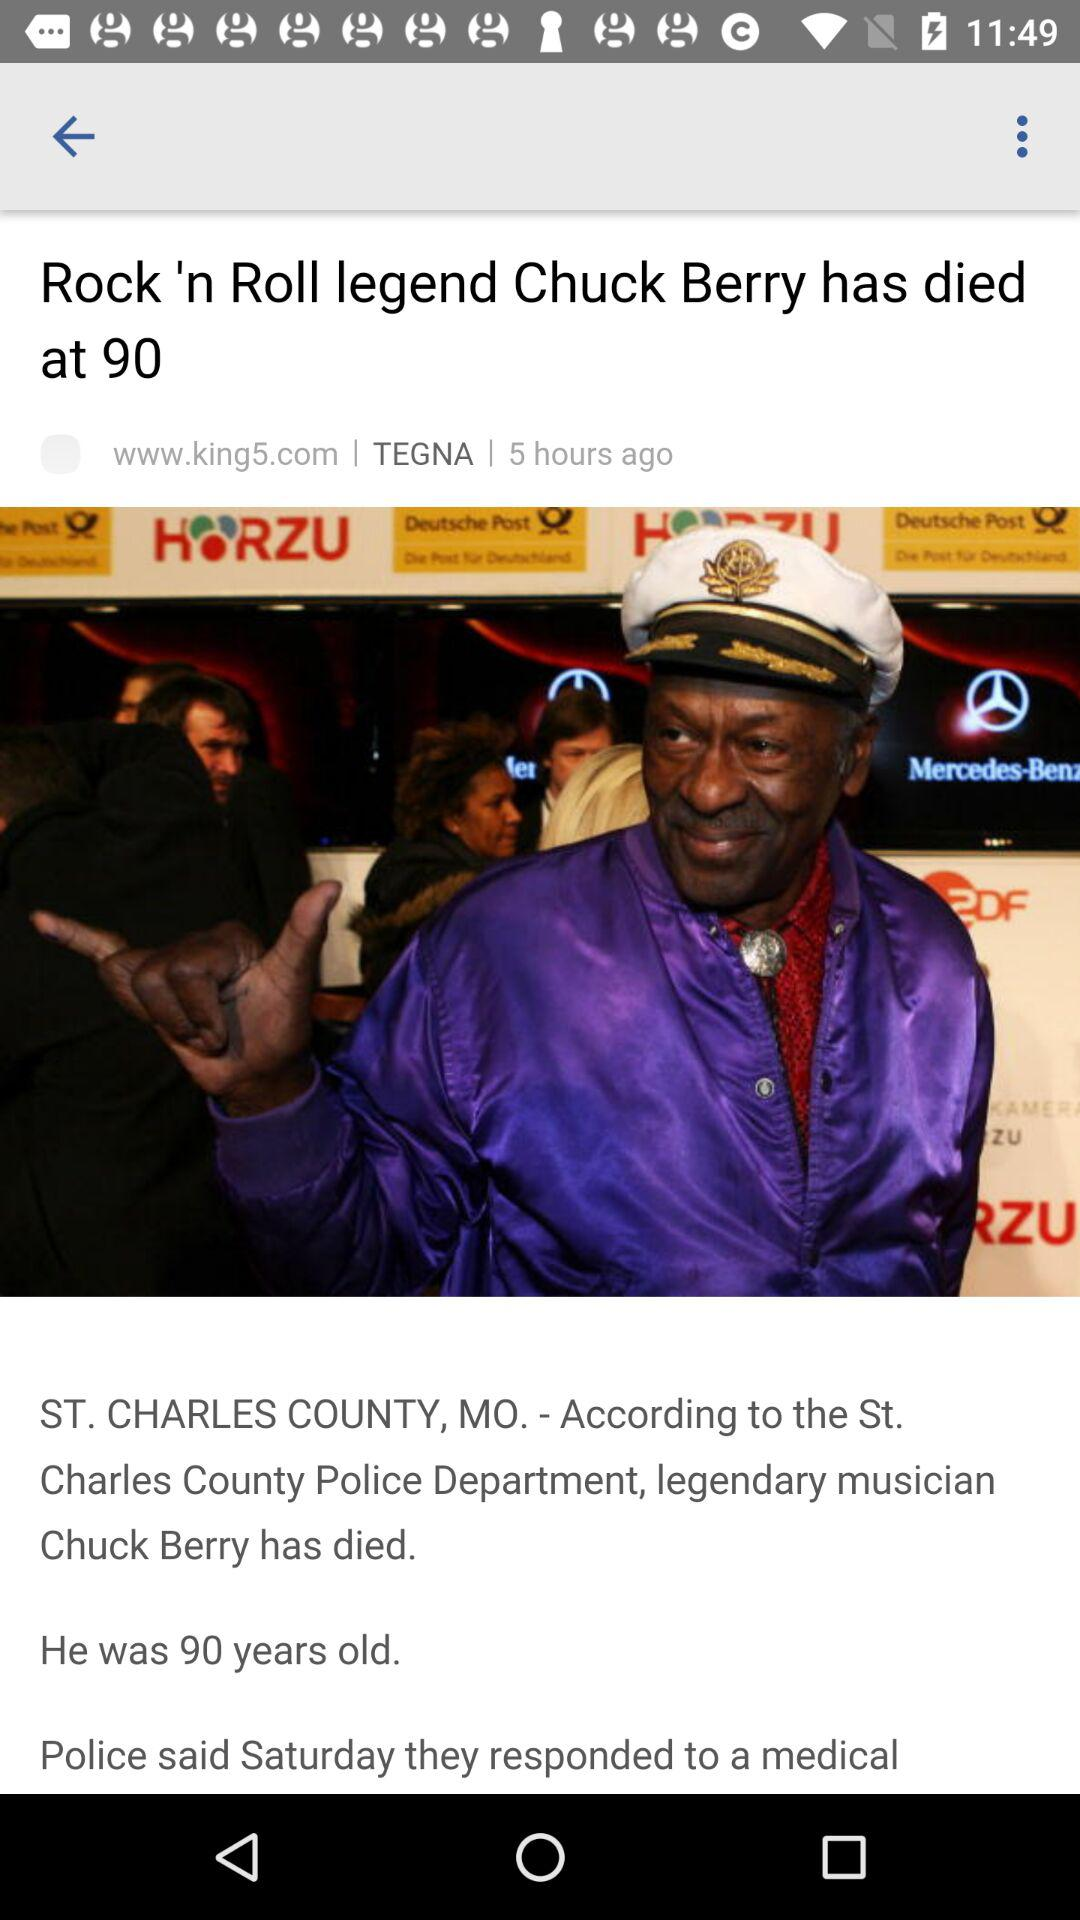At what age did Chuck Berry die? Chuck Berry died at the age of 90. 